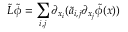<formula> <loc_0><loc_0><loc_500><loc_500>\tilde { L } \tilde { \phi } = \sum _ { i , j } \partial _ { x _ { i } } ( \tilde { a } _ { i , j } \partial _ { x _ { j } } \tilde { \phi } ( x ) )</formula> 